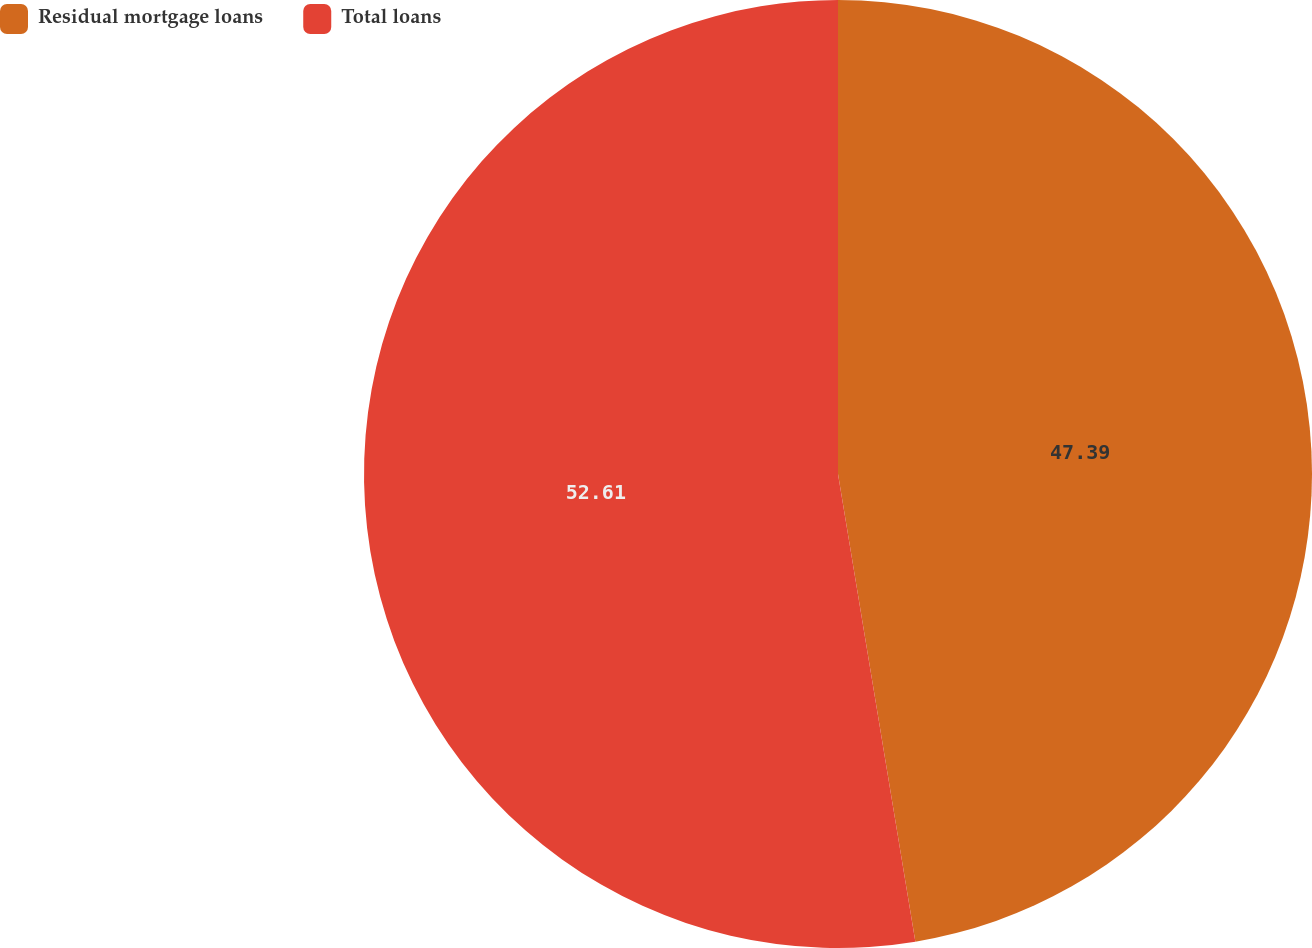<chart> <loc_0><loc_0><loc_500><loc_500><pie_chart><fcel>Residual mortgage loans<fcel>Total loans<nl><fcel>47.39%<fcel>52.61%<nl></chart> 